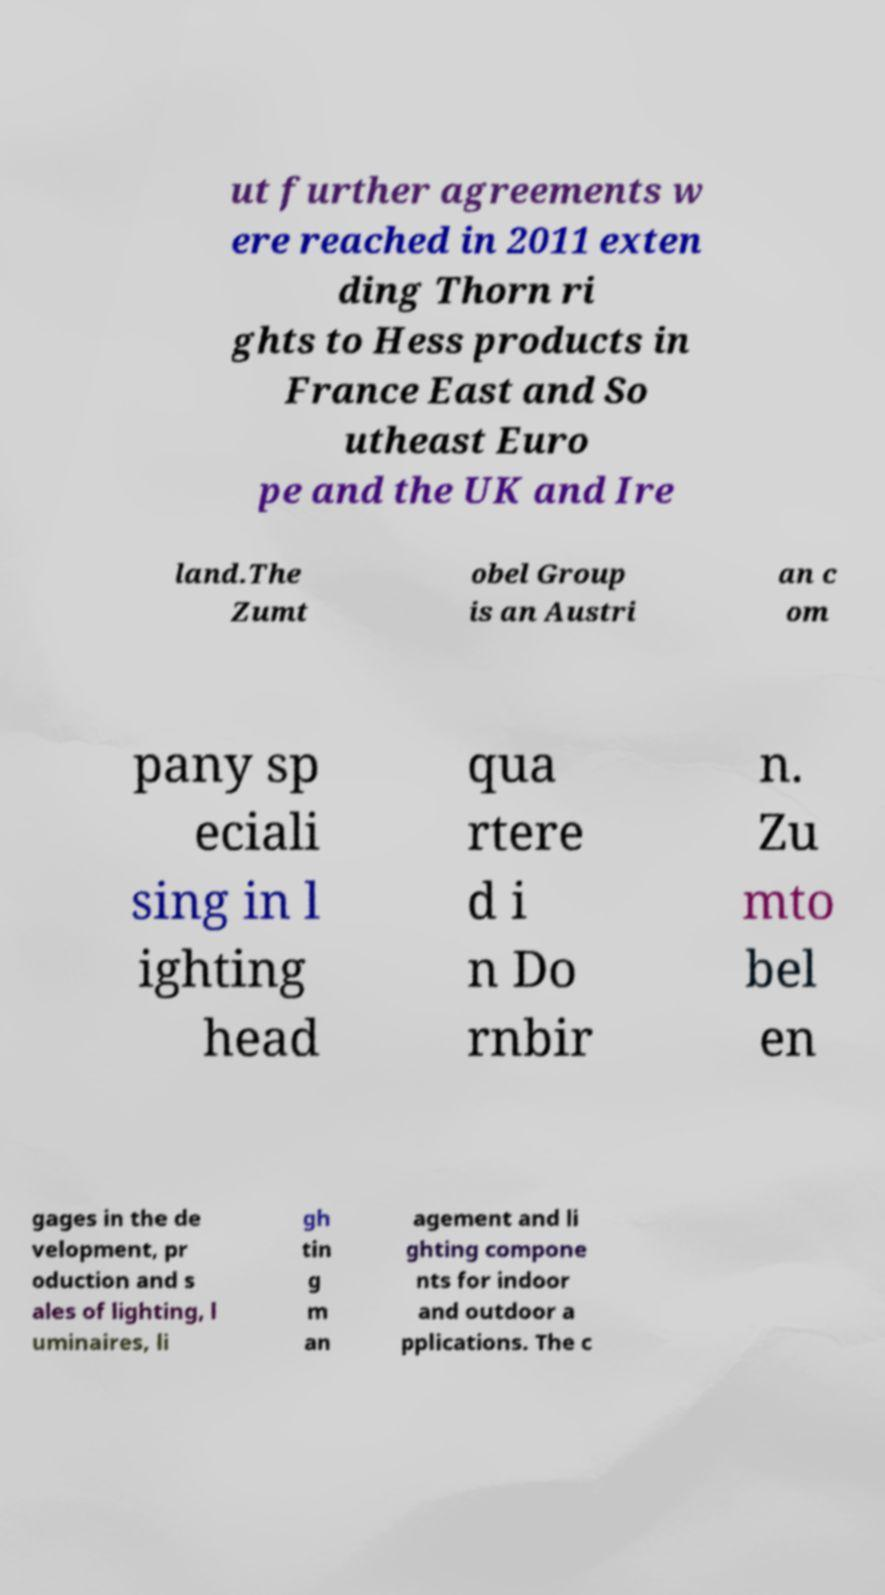Please identify and transcribe the text found in this image. ut further agreements w ere reached in 2011 exten ding Thorn ri ghts to Hess products in France East and So utheast Euro pe and the UK and Ire land.The Zumt obel Group is an Austri an c om pany sp eciali sing in l ighting head qua rtere d i n Do rnbir n. Zu mto bel en gages in the de velopment, pr oduction and s ales of lighting, l uminaires, li gh tin g m an agement and li ghting compone nts for indoor and outdoor a pplications. The c 